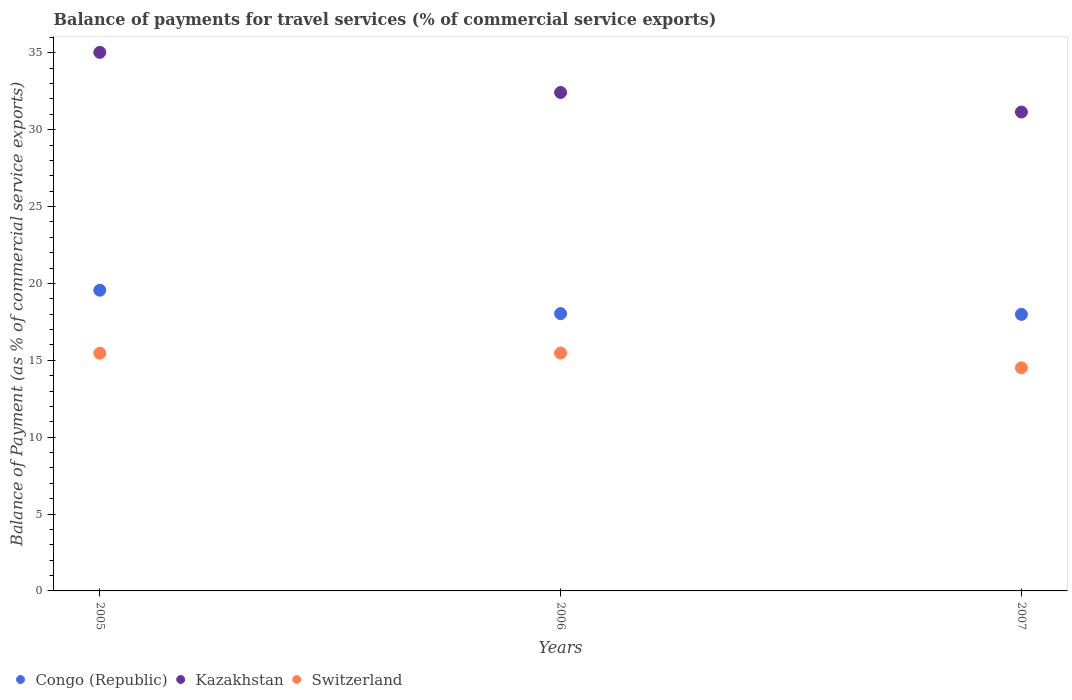How many different coloured dotlines are there?
Your answer should be compact. 3. What is the balance of payments for travel services in Switzerland in 2007?
Ensure brevity in your answer.  14.51. Across all years, what is the maximum balance of payments for travel services in Congo (Republic)?
Give a very brief answer. 19.56. Across all years, what is the minimum balance of payments for travel services in Kazakhstan?
Your answer should be compact. 31.15. In which year was the balance of payments for travel services in Switzerland maximum?
Your response must be concise. 2006. What is the total balance of payments for travel services in Kazakhstan in the graph?
Your answer should be compact. 98.6. What is the difference between the balance of payments for travel services in Switzerland in 2005 and that in 2006?
Ensure brevity in your answer.  -0.01. What is the difference between the balance of payments for travel services in Congo (Republic) in 2005 and the balance of payments for travel services in Kazakhstan in 2007?
Offer a very short reply. -11.59. What is the average balance of payments for travel services in Congo (Republic) per year?
Offer a very short reply. 18.53. In the year 2007, what is the difference between the balance of payments for travel services in Congo (Republic) and balance of payments for travel services in Switzerland?
Give a very brief answer. 3.48. What is the ratio of the balance of payments for travel services in Switzerland in 2005 to that in 2006?
Provide a short and direct response. 1. Is the balance of payments for travel services in Congo (Republic) in 2005 less than that in 2007?
Offer a very short reply. No. Is the difference between the balance of payments for travel services in Congo (Republic) in 2005 and 2007 greater than the difference between the balance of payments for travel services in Switzerland in 2005 and 2007?
Ensure brevity in your answer.  Yes. What is the difference between the highest and the second highest balance of payments for travel services in Congo (Republic)?
Offer a very short reply. 1.52. What is the difference between the highest and the lowest balance of payments for travel services in Kazakhstan?
Ensure brevity in your answer.  3.88. Is the balance of payments for travel services in Switzerland strictly greater than the balance of payments for travel services in Kazakhstan over the years?
Give a very brief answer. No. How many dotlines are there?
Keep it short and to the point. 3. How many years are there in the graph?
Your response must be concise. 3. Are the values on the major ticks of Y-axis written in scientific E-notation?
Offer a very short reply. No. Does the graph contain any zero values?
Provide a succinct answer. No. Does the graph contain grids?
Offer a terse response. No. Where does the legend appear in the graph?
Provide a succinct answer. Bottom left. How are the legend labels stacked?
Your response must be concise. Horizontal. What is the title of the graph?
Your answer should be compact. Balance of payments for travel services (% of commercial service exports). Does "Fiji" appear as one of the legend labels in the graph?
Your answer should be compact. No. What is the label or title of the X-axis?
Your answer should be very brief. Years. What is the label or title of the Y-axis?
Keep it short and to the point. Balance of Payment (as % of commercial service exports). What is the Balance of Payment (as % of commercial service exports) of Congo (Republic) in 2005?
Keep it short and to the point. 19.56. What is the Balance of Payment (as % of commercial service exports) of Kazakhstan in 2005?
Give a very brief answer. 35.03. What is the Balance of Payment (as % of commercial service exports) of Switzerland in 2005?
Your answer should be very brief. 15.46. What is the Balance of Payment (as % of commercial service exports) in Congo (Republic) in 2006?
Ensure brevity in your answer.  18.04. What is the Balance of Payment (as % of commercial service exports) of Kazakhstan in 2006?
Make the answer very short. 32.42. What is the Balance of Payment (as % of commercial service exports) of Switzerland in 2006?
Provide a succinct answer. 15.47. What is the Balance of Payment (as % of commercial service exports) of Congo (Republic) in 2007?
Give a very brief answer. 17.99. What is the Balance of Payment (as % of commercial service exports) in Kazakhstan in 2007?
Keep it short and to the point. 31.15. What is the Balance of Payment (as % of commercial service exports) in Switzerland in 2007?
Provide a succinct answer. 14.51. Across all years, what is the maximum Balance of Payment (as % of commercial service exports) in Congo (Republic)?
Offer a very short reply. 19.56. Across all years, what is the maximum Balance of Payment (as % of commercial service exports) of Kazakhstan?
Offer a terse response. 35.03. Across all years, what is the maximum Balance of Payment (as % of commercial service exports) in Switzerland?
Offer a terse response. 15.47. Across all years, what is the minimum Balance of Payment (as % of commercial service exports) in Congo (Republic)?
Your response must be concise. 17.99. Across all years, what is the minimum Balance of Payment (as % of commercial service exports) in Kazakhstan?
Give a very brief answer. 31.15. Across all years, what is the minimum Balance of Payment (as % of commercial service exports) of Switzerland?
Your answer should be compact. 14.51. What is the total Balance of Payment (as % of commercial service exports) of Congo (Republic) in the graph?
Your response must be concise. 55.58. What is the total Balance of Payment (as % of commercial service exports) of Kazakhstan in the graph?
Keep it short and to the point. 98.6. What is the total Balance of Payment (as % of commercial service exports) of Switzerland in the graph?
Your answer should be very brief. 45.44. What is the difference between the Balance of Payment (as % of commercial service exports) of Congo (Republic) in 2005 and that in 2006?
Offer a very short reply. 1.52. What is the difference between the Balance of Payment (as % of commercial service exports) of Kazakhstan in 2005 and that in 2006?
Offer a terse response. 2.61. What is the difference between the Balance of Payment (as % of commercial service exports) in Switzerland in 2005 and that in 2006?
Provide a succinct answer. -0.01. What is the difference between the Balance of Payment (as % of commercial service exports) of Congo (Republic) in 2005 and that in 2007?
Offer a very short reply. 1.57. What is the difference between the Balance of Payment (as % of commercial service exports) in Kazakhstan in 2005 and that in 2007?
Provide a short and direct response. 3.88. What is the difference between the Balance of Payment (as % of commercial service exports) in Switzerland in 2005 and that in 2007?
Keep it short and to the point. 0.95. What is the difference between the Balance of Payment (as % of commercial service exports) in Congo (Republic) in 2006 and that in 2007?
Provide a short and direct response. 0.05. What is the difference between the Balance of Payment (as % of commercial service exports) of Kazakhstan in 2006 and that in 2007?
Give a very brief answer. 1.27. What is the difference between the Balance of Payment (as % of commercial service exports) in Switzerland in 2006 and that in 2007?
Your response must be concise. 0.96. What is the difference between the Balance of Payment (as % of commercial service exports) in Congo (Republic) in 2005 and the Balance of Payment (as % of commercial service exports) in Kazakhstan in 2006?
Ensure brevity in your answer.  -12.86. What is the difference between the Balance of Payment (as % of commercial service exports) in Congo (Republic) in 2005 and the Balance of Payment (as % of commercial service exports) in Switzerland in 2006?
Offer a terse response. 4.09. What is the difference between the Balance of Payment (as % of commercial service exports) in Kazakhstan in 2005 and the Balance of Payment (as % of commercial service exports) in Switzerland in 2006?
Provide a succinct answer. 19.56. What is the difference between the Balance of Payment (as % of commercial service exports) of Congo (Republic) in 2005 and the Balance of Payment (as % of commercial service exports) of Kazakhstan in 2007?
Provide a short and direct response. -11.59. What is the difference between the Balance of Payment (as % of commercial service exports) in Congo (Republic) in 2005 and the Balance of Payment (as % of commercial service exports) in Switzerland in 2007?
Your answer should be compact. 5.05. What is the difference between the Balance of Payment (as % of commercial service exports) in Kazakhstan in 2005 and the Balance of Payment (as % of commercial service exports) in Switzerland in 2007?
Your answer should be compact. 20.52. What is the difference between the Balance of Payment (as % of commercial service exports) of Congo (Republic) in 2006 and the Balance of Payment (as % of commercial service exports) of Kazakhstan in 2007?
Your answer should be very brief. -13.11. What is the difference between the Balance of Payment (as % of commercial service exports) in Congo (Republic) in 2006 and the Balance of Payment (as % of commercial service exports) in Switzerland in 2007?
Keep it short and to the point. 3.53. What is the difference between the Balance of Payment (as % of commercial service exports) of Kazakhstan in 2006 and the Balance of Payment (as % of commercial service exports) of Switzerland in 2007?
Make the answer very short. 17.91. What is the average Balance of Payment (as % of commercial service exports) of Congo (Republic) per year?
Your response must be concise. 18.53. What is the average Balance of Payment (as % of commercial service exports) of Kazakhstan per year?
Make the answer very short. 32.87. What is the average Balance of Payment (as % of commercial service exports) of Switzerland per year?
Make the answer very short. 15.15. In the year 2005, what is the difference between the Balance of Payment (as % of commercial service exports) in Congo (Republic) and Balance of Payment (as % of commercial service exports) in Kazakhstan?
Your response must be concise. -15.47. In the year 2005, what is the difference between the Balance of Payment (as % of commercial service exports) of Congo (Republic) and Balance of Payment (as % of commercial service exports) of Switzerland?
Your response must be concise. 4.1. In the year 2005, what is the difference between the Balance of Payment (as % of commercial service exports) in Kazakhstan and Balance of Payment (as % of commercial service exports) in Switzerland?
Keep it short and to the point. 19.57. In the year 2006, what is the difference between the Balance of Payment (as % of commercial service exports) of Congo (Republic) and Balance of Payment (as % of commercial service exports) of Kazakhstan?
Provide a short and direct response. -14.38. In the year 2006, what is the difference between the Balance of Payment (as % of commercial service exports) in Congo (Republic) and Balance of Payment (as % of commercial service exports) in Switzerland?
Your response must be concise. 2.56. In the year 2006, what is the difference between the Balance of Payment (as % of commercial service exports) of Kazakhstan and Balance of Payment (as % of commercial service exports) of Switzerland?
Your response must be concise. 16.95. In the year 2007, what is the difference between the Balance of Payment (as % of commercial service exports) of Congo (Republic) and Balance of Payment (as % of commercial service exports) of Kazakhstan?
Offer a terse response. -13.16. In the year 2007, what is the difference between the Balance of Payment (as % of commercial service exports) of Congo (Republic) and Balance of Payment (as % of commercial service exports) of Switzerland?
Provide a succinct answer. 3.48. In the year 2007, what is the difference between the Balance of Payment (as % of commercial service exports) in Kazakhstan and Balance of Payment (as % of commercial service exports) in Switzerland?
Offer a very short reply. 16.64. What is the ratio of the Balance of Payment (as % of commercial service exports) of Congo (Republic) in 2005 to that in 2006?
Make the answer very short. 1.08. What is the ratio of the Balance of Payment (as % of commercial service exports) in Kazakhstan in 2005 to that in 2006?
Provide a short and direct response. 1.08. What is the ratio of the Balance of Payment (as % of commercial service exports) of Congo (Republic) in 2005 to that in 2007?
Your response must be concise. 1.09. What is the ratio of the Balance of Payment (as % of commercial service exports) in Kazakhstan in 2005 to that in 2007?
Make the answer very short. 1.12. What is the ratio of the Balance of Payment (as % of commercial service exports) of Switzerland in 2005 to that in 2007?
Keep it short and to the point. 1.07. What is the ratio of the Balance of Payment (as % of commercial service exports) of Kazakhstan in 2006 to that in 2007?
Offer a terse response. 1.04. What is the ratio of the Balance of Payment (as % of commercial service exports) in Switzerland in 2006 to that in 2007?
Your response must be concise. 1.07. What is the difference between the highest and the second highest Balance of Payment (as % of commercial service exports) in Congo (Republic)?
Offer a very short reply. 1.52. What is the difference between the highest and the second highest Balance of Payment (as % of commercial service exports) of Kazakhstan?
Your answer should be very brief. 2.61. What is the difference between the highest and the second highest Balance of Payment (as % of commercial service exports) of Switzerland?
Your answer should be compact. 0.01. What is the difference between the highest and the lowest Balance of Payment (as % of commercial service exports) of Congo (Republic)?
Offer a terse response. 1.57. What is the difference between the highest and the lowest Balance of Payment (as % of commercial service exports) of Kazakhstan?
Offer a terse response. 3.88. What is the difference between the highest and the lowest Balance of Payment (as % of commercial service exports) in Switzerland?
Offer a very short reply. 0.96. 